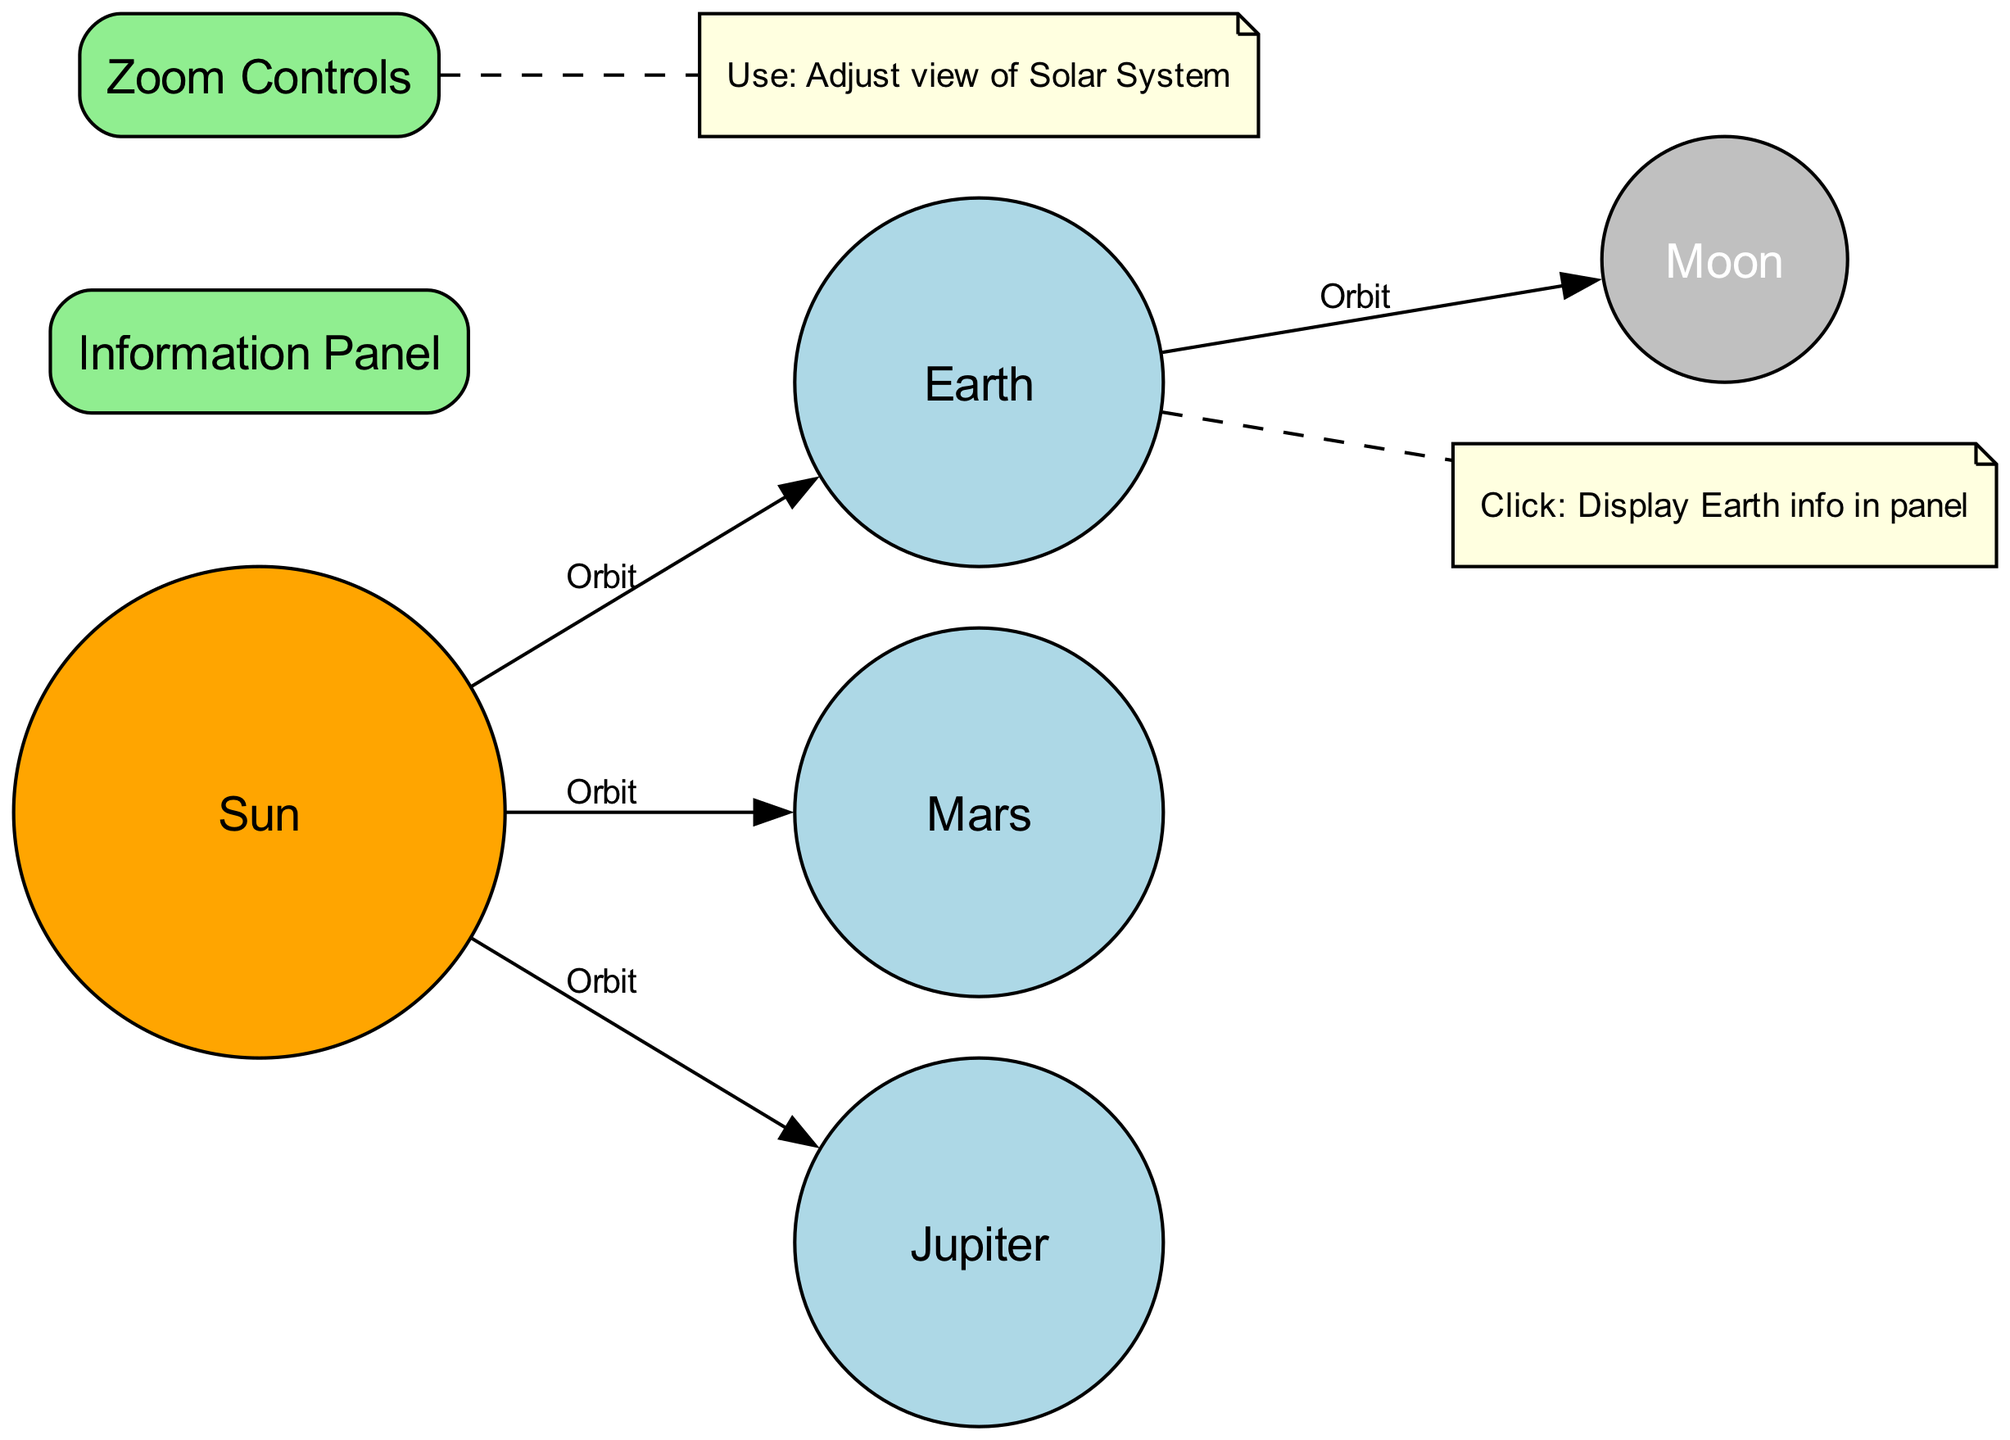What is the central body of the Solar System? The diagram shows that the "Sun" is the central body, denoted as a central body type in the nodes.
Answer: Sun How many planets are represented in the diagram? The nodes include "Earth," "Mars," and "Jupiter" as planets, totaling three planets.
Answer: 3 What color is used to represent moons in the diagram? The "Moon" node is colored gray, which indicates its type as a moon.
Answer: Gray Which planet is directly connected to the Moon? The edge connecting "Earth" to "Moon" shows that the Moon is in orbit around the Earth.
Answer: Earth What action can be taken on the zoom controls? The interaction defined indicates that the action taken on "zoom_controls" is to "Use," allowing adjustments to the view of the Solar System.
Answer: Adjust view What will happen if you click on the Earth? The diagram specifies that clicking on "Earth" will display information about Earth in the information panel.
Answer: Display Earth info in panel How many total edges are present in the diagram? The edges include connections from "Sun" to "Earth," "Earth" to "Moon," "Sun" to "Mars," and "Sun" to "Jupiter," resulting in four edges in total.
Answer: 4 What is the purpose of the information panel? The information panel is classified as a UI element and serves to show information when users interact with certain nodes, such as planets.
Answer: Show information Which planet orbits closest to the Sun in this diagram? Among the listed planets, "Earth" orbits the Sun, but it is not the closest; "Mars" is further out, making the connections lead to "Mercury" which isn't shown. However, based on available data, we would consider the closest planet as unspecified.
Answer: Unspecified What type of element is "Zoom Controls"? In the node types listed, "Zoom Controls" is classified specifically as a UI element according to the diagram structure.
Answer: UI element 